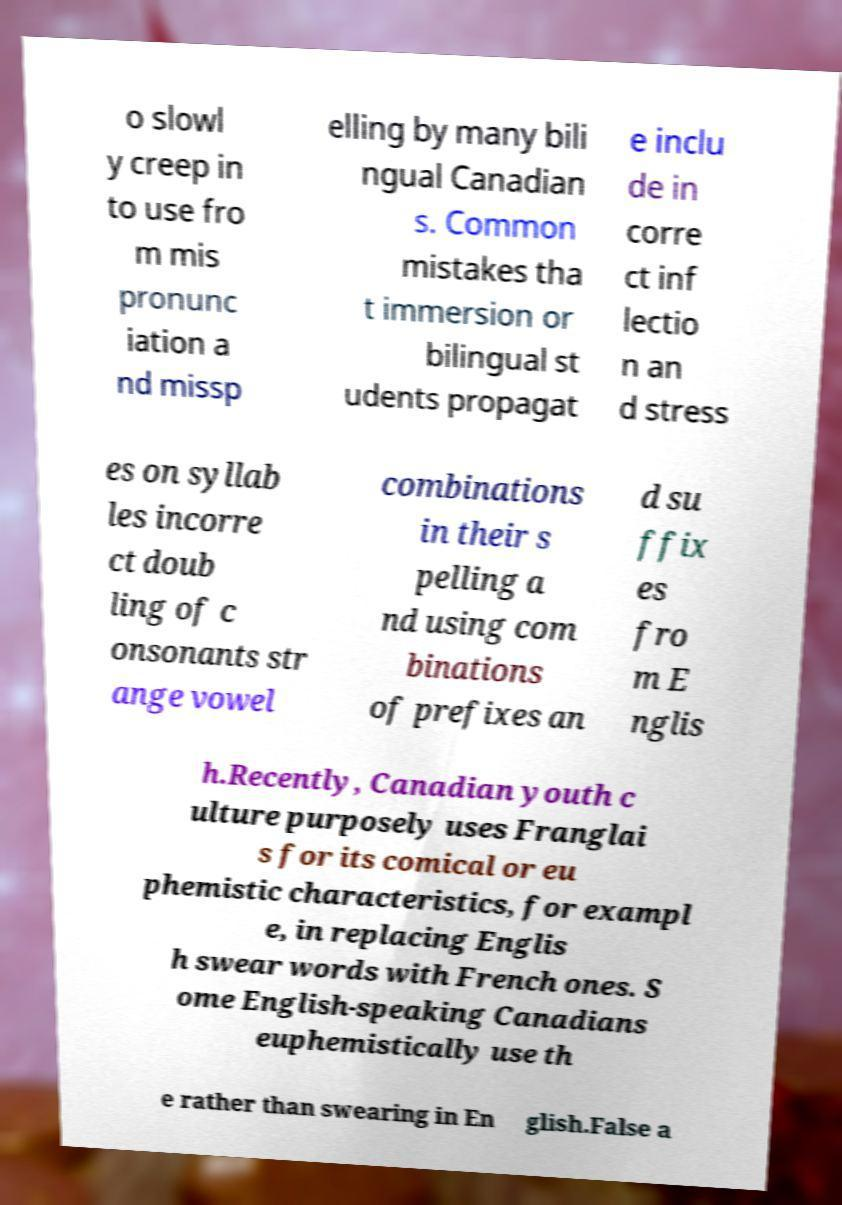What messages or text are displayed in this image? I need them in a readable, typed format. o slowl y creep in to use fro m mis pronunc iation a nd missp elling by many bili ngual Canadian s. Common mistakes tha t immersion or bilingual st udents propagat e inclu de in corre ct inf lectio n an d stress es on syllab les incorre ct doub ling of c onsonants str ange vowel combinations in their s pelling a nd using com binations of prefixes an d su ffix es fro m E nglis h.Recently, Canadian youth c ulture purposely uses Franglai s for its comical or eu phemistic characteristics, for exampl e, in replacing Englis h swear words with French ones. S ome English-speaking Canadians euphemistically use th e rather than swearing in En glish.False a 